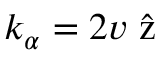<formula> <loc_0><loc_0><loc_500><loc_500>{ k _ { \alpha } = 2 v \hat { z } }</formula> 